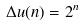Convert formula to latex. <formula><loc_0><loc_0><loc_500><loc_500>\Delta u ( n ) = 2 ^ { n }</formula> 